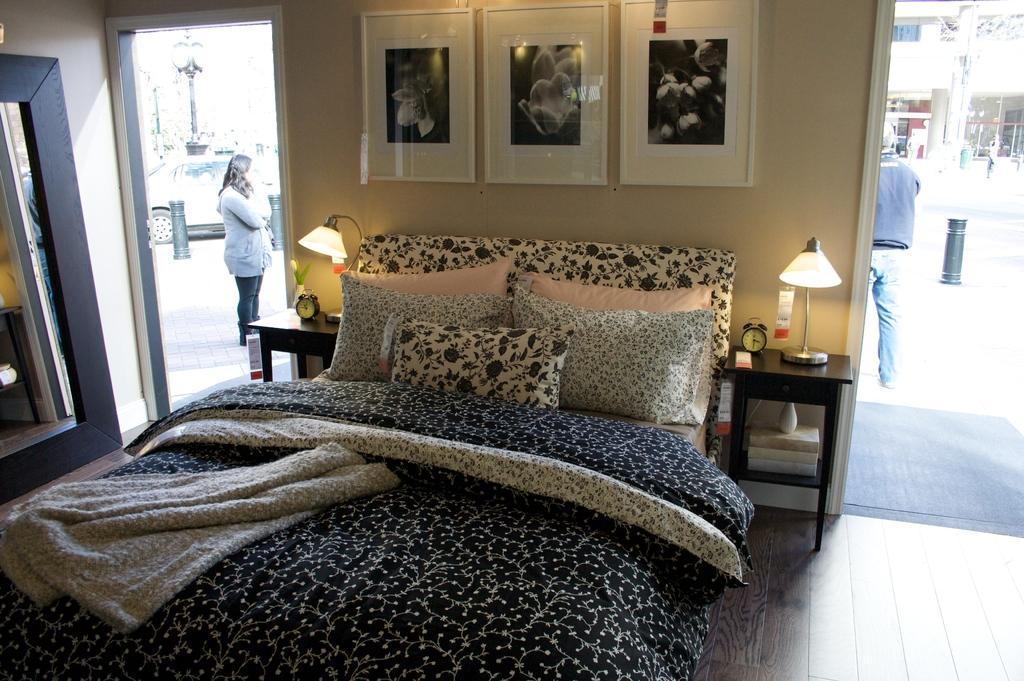In one or two sentences, can you explain what this image depicts? In this image I can see a pillows on the bed. There is blanket on the bed. On the table there is a lamp and a clock. At the back side we can see a woman standing on the road we can see vehicles on the road. On the wall there are frames. 